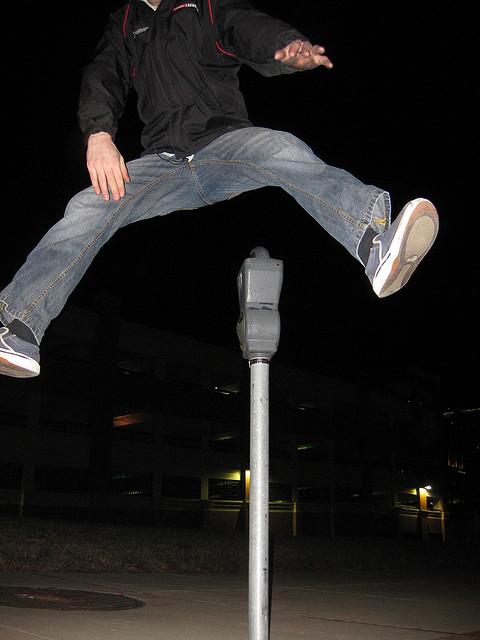Is it dark?
Quick response, please. Yes. What is this person jumping over?
Give a very brief answer. Parking meter. What kind of pants is the person wearing?
Be succinct. Jeans. 